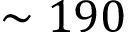Convert formula to latex. <formula><loc_0><loc_0><loc_500><loc_500>\sim 1 9 0</formula> 